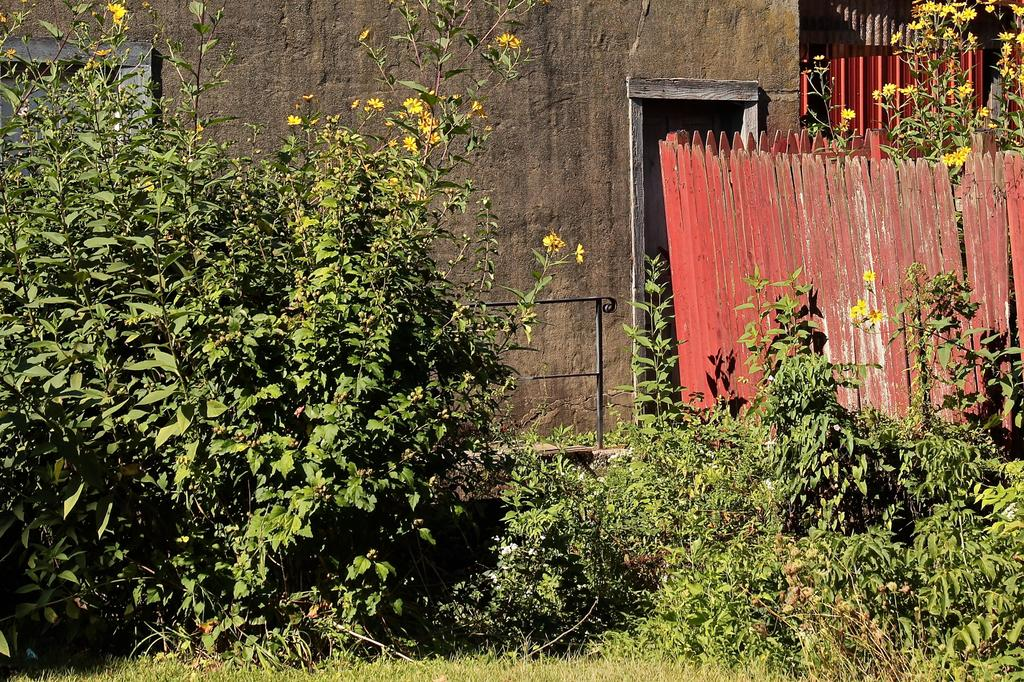What type of living organisms can be seen in the image? Plants can be seen in the image, with flowers growing on them. What is visible in the background of the image? There is a house and red-colored wooden fencing in the background of the image. How many swings can be seen hanging from the trees in the image? There are no swings or trees present in the image; it features plants with flowers and a background with a house and red-colored wooden fencing. 